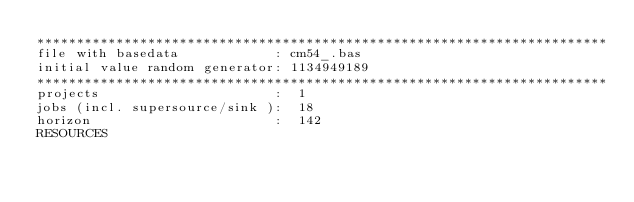<code> <loc_0><loc_0><loc_500><loc_500><_ObjectiveC_>************************************************************************
file with basedata            : cm54_.bas
initial value random generator: 1134949189
************************************************************************
projects                      :  1
jobs (incl. supersource/sink ):  18
horizon                       :  142
RESOURCES</code> 